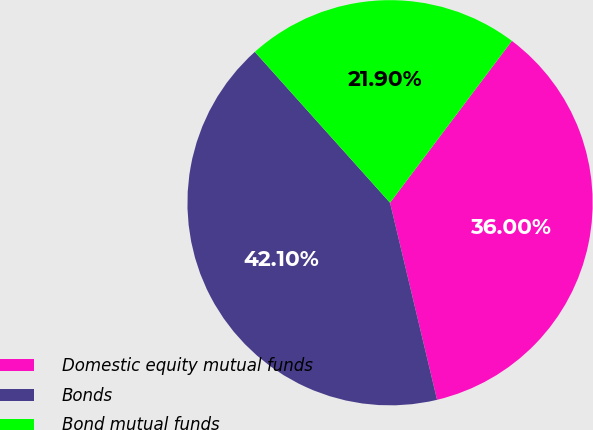Convert chart. <chart><loc_0><loc_0><loc_500><loc_500><pie_chart><fcel>Domestic equity mutual funds<fcel>Bonds<fcel>Bond mutual funds<nl><fcel>36.0%<fcel>42.1%<fcel>21.9%<nl></chart> 